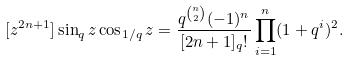Convert formula to latex. <formula><loc_0><loc_0><loc_500><loc_500>[ z ^ { 2 n + 1 } ] \sin _ { q } z \cos _ { 1 / q } z = \frac { q ^ { \binom { n } 2 } { ( - 1 ) ^ { n } } } { [ 2 n + 1 ] _ { q } ! } \prod _ { i = 1 } ^ { n } ( 1 + q ^ { i } ) ^ { 2 } .</formula> 